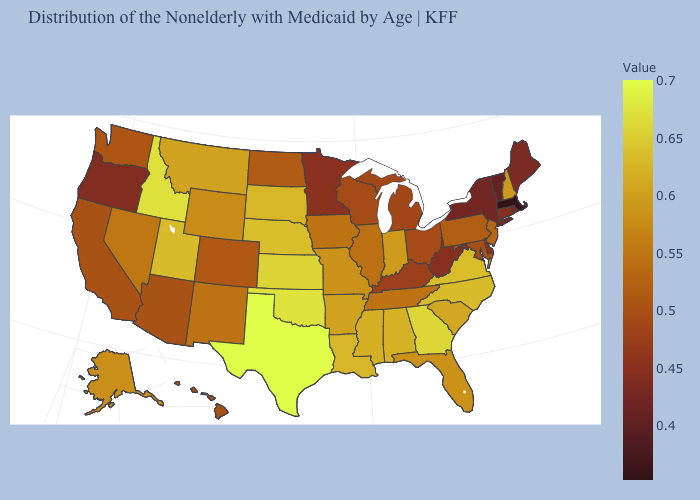Does Vermont have the highest value in the Northeast?
Write a very short answer. No. Does Pennsylvania have a lower value than New York?
Write a very short answer. No. Does the map have missing data?
Answer briefly. No. Which states have the lowest value in the USA?
Give a very brief answer. Massachusetts. Does Massachusetts have the lowest value in the Northeast?
Be succinct. Yes. 